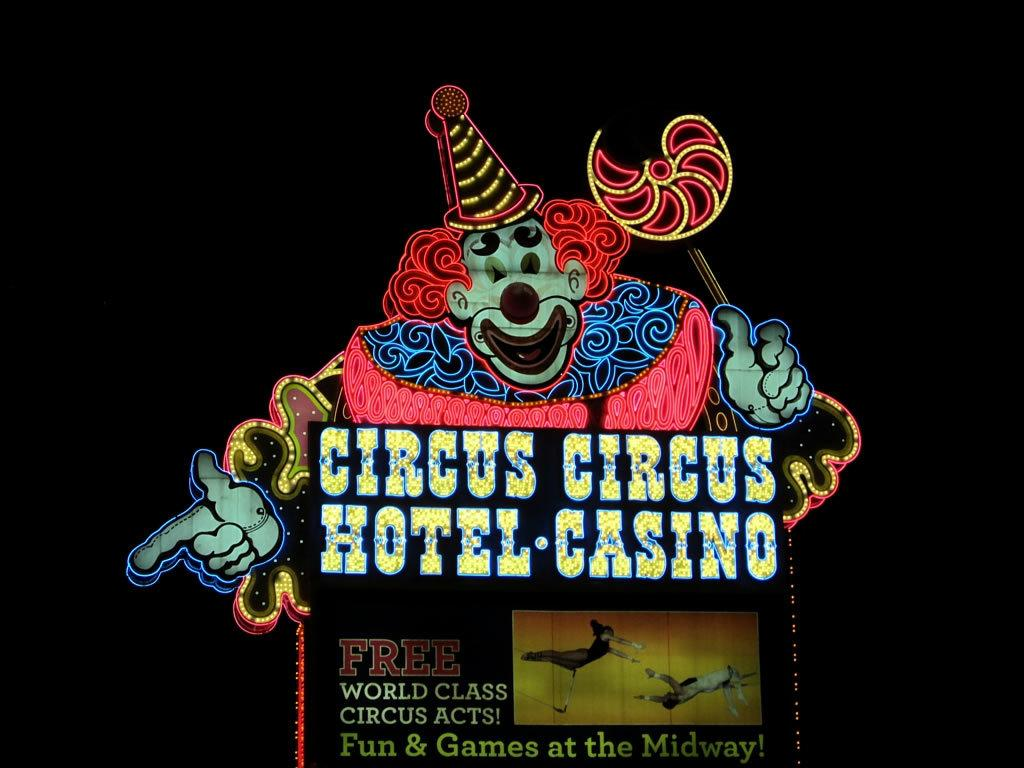Provide a one-sentence caption for the provided image. A neon clown on a sign advertising the Circus Circus hotel and Casino. 